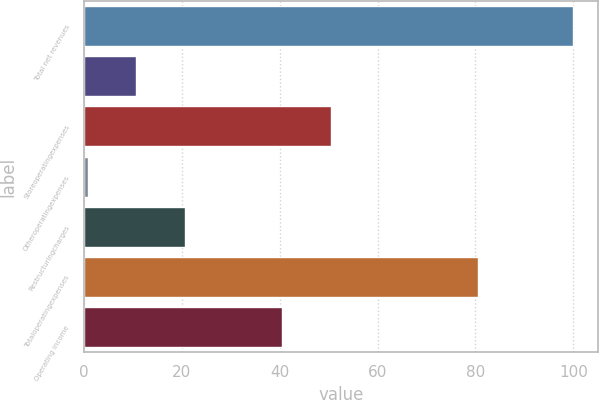Convert chart to OTSL. <chart><loc_0><loc_0><loc_500><loc_500><bar_chart><fcel>Total net revenues<fcel>Unnamed: 1<fcel>Storeoperatingexpenses<fcel>Otheroperatingexpenses<fcel>Restructuringcharges<fcel>Totaloperatingexpenses<fcel>Operating income<nl><fcel>100<fcel>10.72<fcel>50.4<fcel>0.8<fcel>20.64<fcel>80.6<fcel>40.48<nl></chart> 